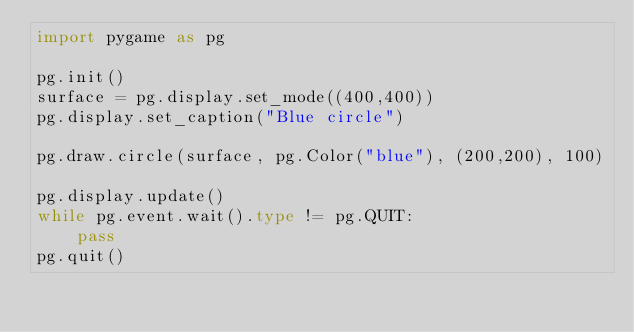Convert code to text. <code><loc_0><loc_0><loc_500><loc_500><_Python_>import pygame as pg

pg.init()
surface = pg.display.set_mode((400,400))
pg.display.set_caption("Blue circle")

pg.draw.circle(surface, pg.Color("blue"), (200,200), 100)

pg.display.update()
while pg.event.wait().type != pg.QUIT:
    pass
pg.quit()
</code> 